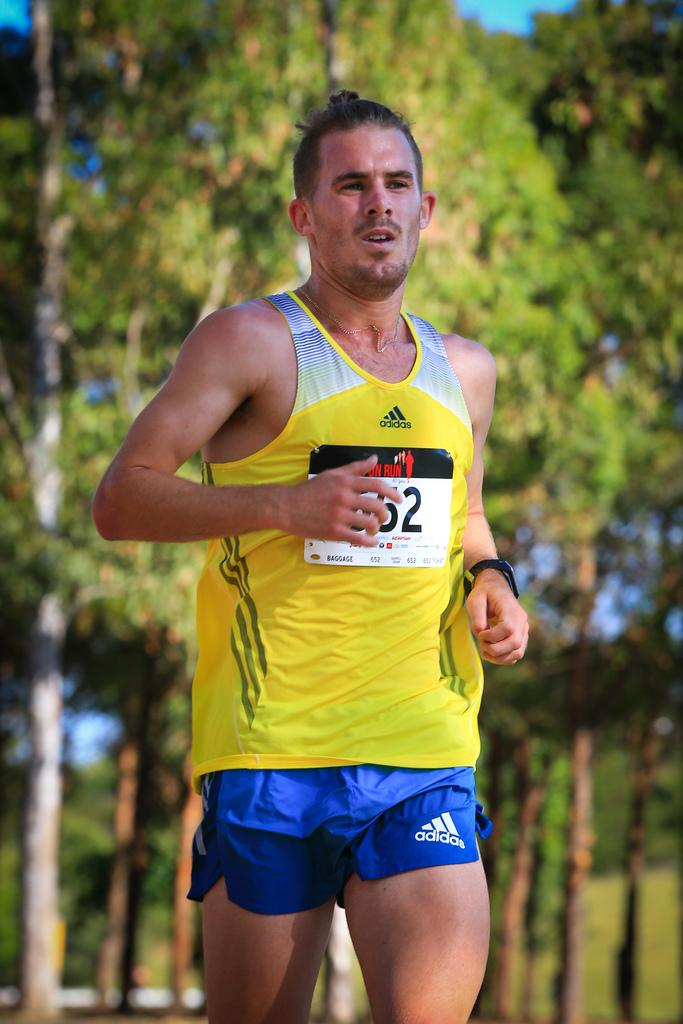<image>
Describe the image concisely. A man running with a yellow shirt and blue shorts from Adidas. 